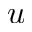Convert formula to latex. <formula><loc_0><loc_0><loc_500><loc_500>u</formula> 